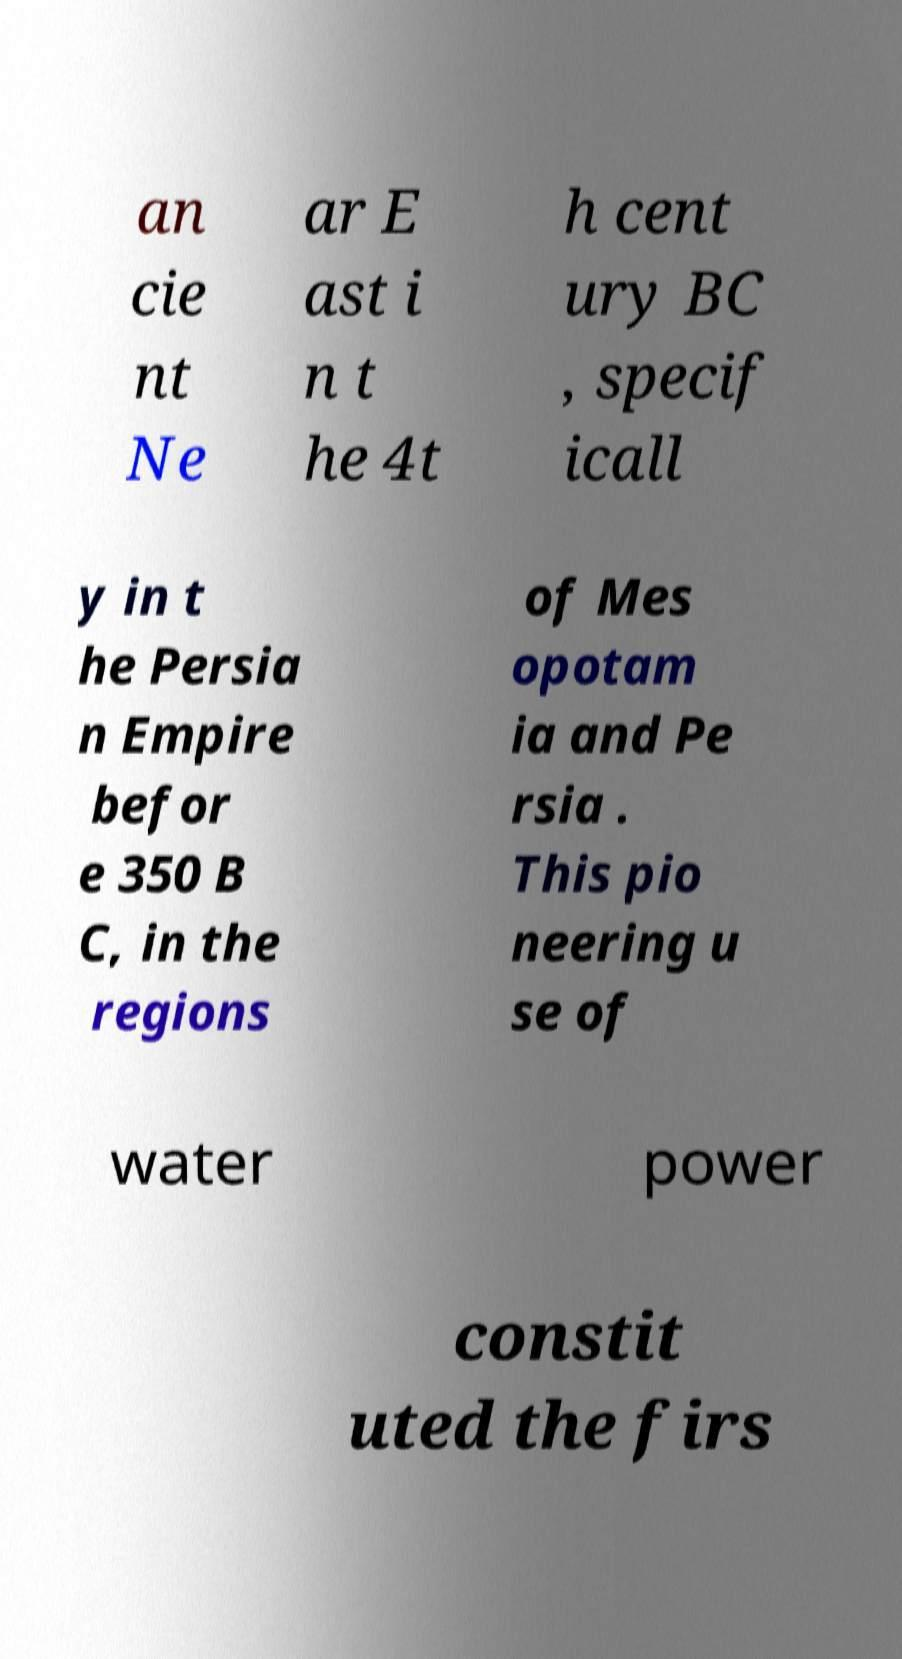Could you extract and type out the text from this image? an cie nt Ne ar E ast i n t he 4t h cent ury BC , specif icall y in t he Persia n Empire befor e 350 B C, in the regions of Mes opotam ia and Pe rsia . This pio neering u se of water power constit uted the firs 